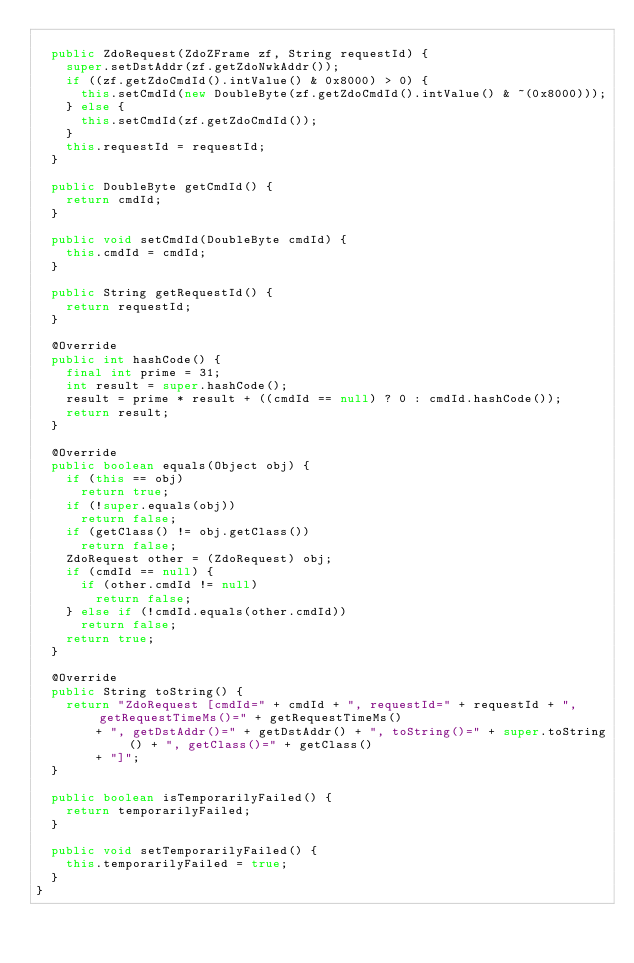Convert code to text. <code><loc_0><loc_0><loc_500><loc_500><_Java_>	
	public ZdoRequest(ZdoZFrame zf, String requestId) {
		super.setDstAddr(zf.getZdoNwkAddr());
		if ((zf.getZdoCmdId().intValue() & 0x8000) > 0) {
			this.setCmdId(new DoubleByte(zf.getZdoCmdId().intValue() & ~(0x8000)));
		} else {
			this.setCmdId(zf.getZdoCmdId());
		}
		this.requestId = requestId;
	}
	
	public DoubleByte getCmdId() {
		return cmdId;
	}
	
	public void setCmdId(DoubleByte cmdId) {
		this.cmdId = cmdId;
	}
	
	public String getRequestId() {
		return requestId;
	}

	@Override
	public int hashCode() {
		final int prime = 31;
		int result = super.hashCode();
		result = prime * result + ((cmdId == null) ? 0 : cmdId.hashCode());
		return result;
	}

	@Override
	public boolean equals(Object obj) {
		if (this == obj)
			return true;
		if (!super.equals(obj))
			return false;
		if (getClass() != obj.getClass())
			return false;
		ZdoRequest other = (ZdoRequest) obj;
		if (cmdId == null) {
			if (other.cmdId != null)
				return false;
		} else if (!cmdId.equals(other.cmdId))
			return false;
		return true;
	}

	@Override
	public String toString() {
		return "ZdoRequest [cmdId=" + cmdId + ", requestId=" + requestId + ", getRequestTimeMs()=" + getRequestTimeMs()
				+ ", getDstAddr()=" + getDstAddr() + ", toString()=" + super.toString() + ", getClass()=" + getClass()
				+ "]";
	}

	public boolean isTemporarilyFailed() {
		return temporarilyFailed;
	}

	public void setTemporarilyFailed() {
		this.temporarilyFailed = true;
	}
}
</code> 